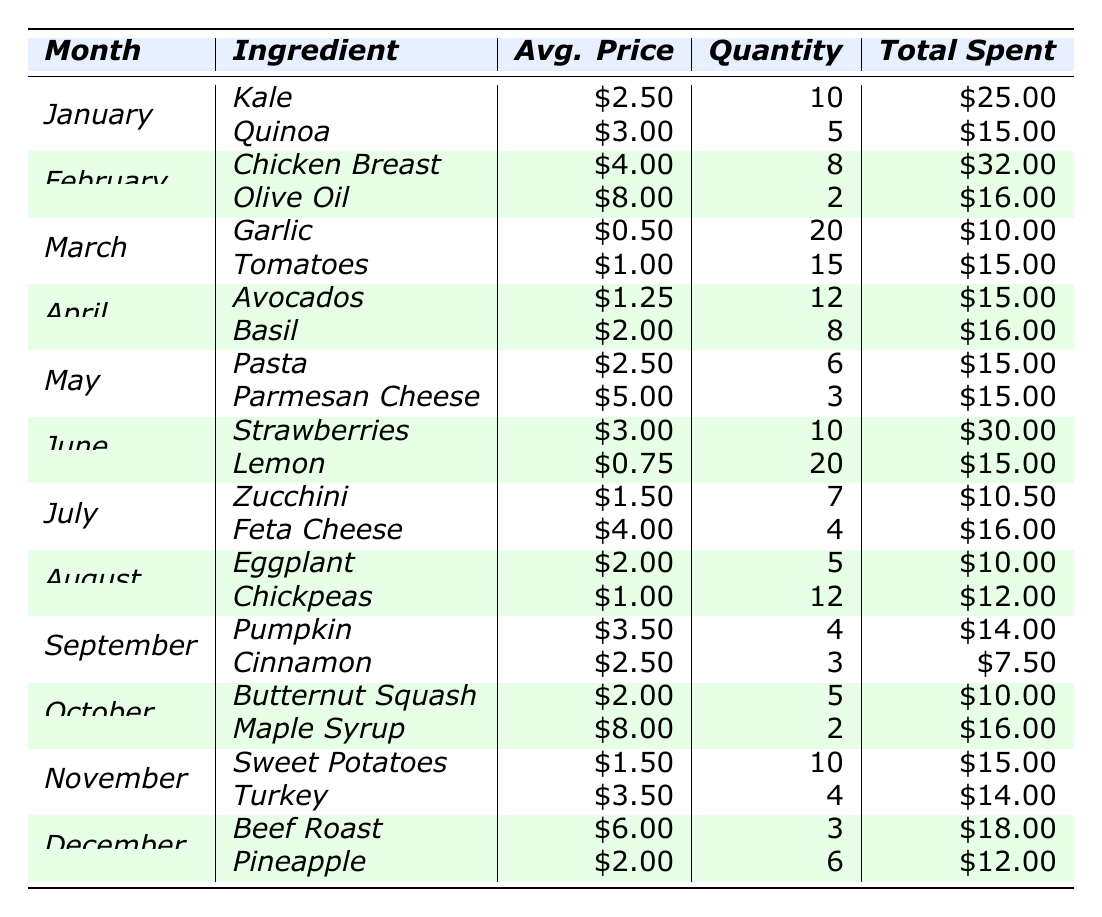What ingredient had the highest total spent in February? In February, Chicken Breast had a total spent of $32.00, which is higher than Olive Oil's total spent of $16.00.
Answer: Chicken Breast What month had the highest overall spending? To determine this, we need to sum the total spent for each month: January ($40), February ($48), March ($25), April ($31), May ($30), June ($45), July ($26.50), August ($22), September ($21.50), October ($26), November ($29), December ($30). The highest total is February with $48.
Answer: February How many total ingredients were purchased in June? In June, there were two ingredients: Strawberries (10 units) and Lemon (20 units). Adding these gives 10 + 20 = 30.
Answer: 30 What was the average price per unit of ingredients in October? The average price per unit in October can be calculated from Butternut Squash ($2.00) and Maple Syrup ($8.00). We sum $2.00 + $8.00 = $10.00 and divide by 2 (number of ingredients) giving $10.00 / 2 = $5.00.
Answer: $5.00 Did the total spent on zucchini exceed that of eggplant in July? The total spent on Zucchini was $10.50, while the total for Eggplant was $10.00. Since $10.50 > $10.00, it is true that Zucchini's total spent exceeded Eggplant's.
Answer: Yes What was the difference in total spent between January and February? January's total spent was $40, while February's total is $48. The difference is $48 - $40 = $8.
Answer: $8 Which ingredient had the lowest average price per unit in March? In March, the average prices were Garlic ($0.50) and Tomatoes ($1.00). Garlic has the lowest price of $0.50.
Answer: Garlic What is the total quantity of ingredients purchased across the entire year? We sum the quantities purchased for all months: 10 + 5 + 8 + 2 + 20 + 15 + 12 + 8 + 6 + 3 + 10 + 4 + 3 + 6 = 169.
Answer: 169 What month had the least number of different ingredients purchased? By checking the months, January, February, March, April, May, June, July, August, September, October, November, and December each had 2 ingredients. They all have the same number, so there's no single least month.
Answer: None; all months had 2 ingredients Which ingredient cost the most per unit in the table? Looking at the average prices per unit, Olive Oil had the highest average price at $8.00.
Answer: Olive Oil 